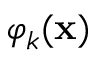<formula> <loc_0><loc_0><loc_500><loc_500>\varphi _ { k } ( { x } )</formula> 